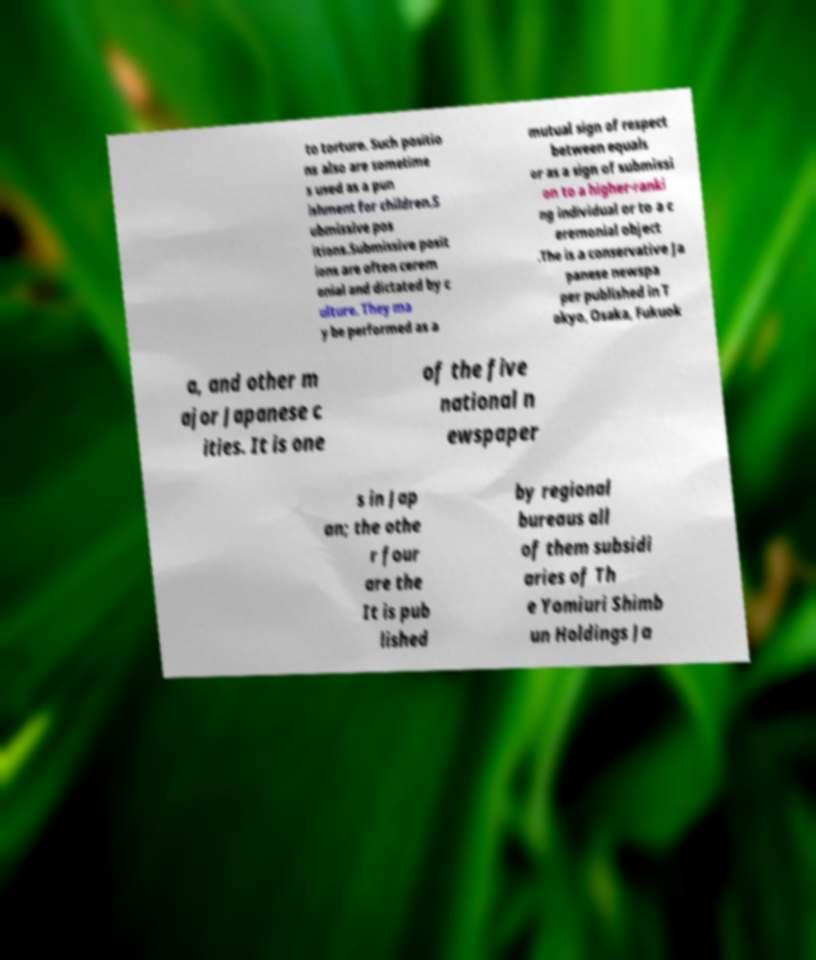Please identify and transcribe the text found in this image. to torture. Such positio ns also are sometime s used as a pun ishment for children.S ubmissive pos itions.Submissive posit ions are often cerem onial and dictated by c ulture. They ma y be performed as a mutual sign of respect between equals or as a sign of submissi on to a higher-ranki ng individual or to a c eremonial object .The is a conservative Ja panese newspa per published in T okyo, Osaka, Fukuok a, and other m ajor Japanese c ities. It is one of the five national n ewspaper s in Jap an; the othe r four are the It is pub lished by regional bureaus all of them subsidi aries of Th e Yomiuri Shimb un Holdings Ja 